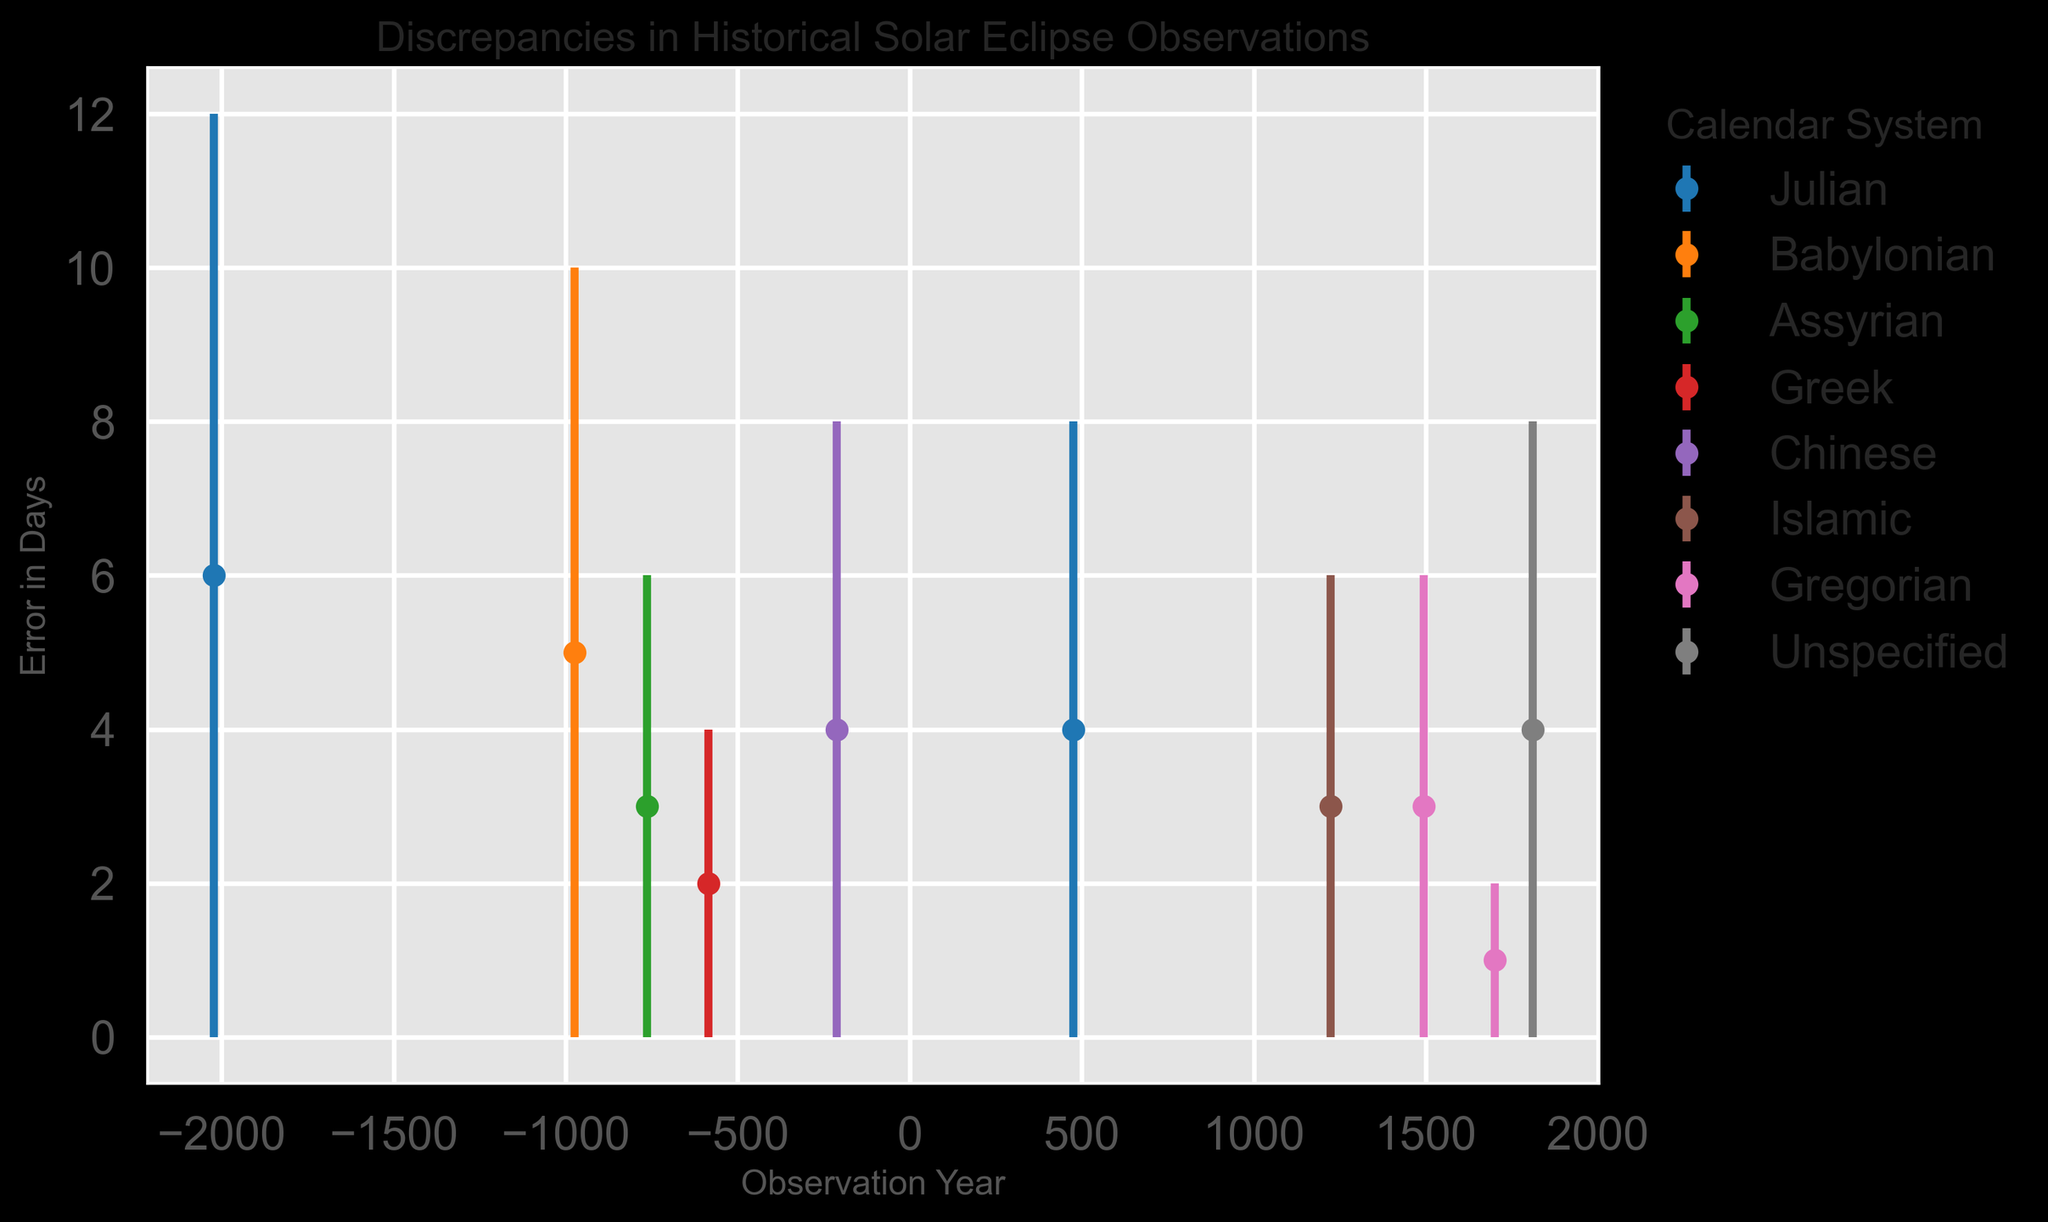Which calendar system exhibits the largest error range in days? By examining the figure, we need to identify the calendar system with the highest error value displayed as error bars. The Julian system at -2023 has an error of 6 days, the largest in the chart.
Answer: Julian Which calendar systems have an identical error value of 3 days? By looking at the error values on the chart, we see the Assyrian system (-763), Islamic system (1223), Gregorian system (1493) have identical errors of 3 days.
Answer: Assyrian, Islamic, Gregorian What is the average error in days across all calendar systems for observations prior to the Common Era (BCE)? Identify the error values for observations before the Common Era (-2023, -975, -763, -585, -213). Sum the errors: 6 + 5 + 3 + 2 + 4 = 20 days. There are 5 observations, so the average error is 20 / 5.
Answer: 4 days Which calendar system has the smallest error value and what is the value? Find the minimum error value observed in the chart. The Gregorian system in 1700 shows an error value of 1 day.
Answer: Gregorian, 1 day During which observation year did the Julian calendar system have a recorded error, and what was the error value? Locate the points correlating to the Julian calendar system. The Julian calendar is shown in -2023 with an error of 6 days and in 476 with an error of 4 days.
Answer: -2023, 6 days For the observation made in the year 1811, what is the reported error in days? Identify the error bar corresponding to the year 1811. The error value shown is 4 days.
Answer: 4 days Do the observation errors increase or decrease over time for the Julian calendar system? By visually tracking the error values of the Julian calendar system through the timeline points, it appears the error decreases (from 6 days in -2023 to 4 days in 476).
Answer: Decrease What is the difference in error values between the Chinese system and Assyrian system? Identify the error values: Chinese system (-213) has an error value of 4 days, Assyrian system (-763) has an error value of 3 days. Calculate the difference: 4 - 3.
Answer: 1 day Which observation year had the highest error recorded and what calendar system was it associated with? By looking at the chart, the highest error recorded is 6 days in -2023 associated with the Julian calendar system.
Answer: -2023, Julian system 